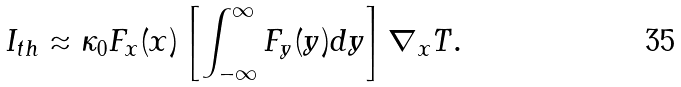Convert formula to latex. <formula><loc_0><loc_0><loc_500><loc_500>I _ { t h } \approx \kappa _ { 0 } F _ { x } ( x ) \left [ \int _ { - \infty } ^ { \infty } F _ { y } ( y ) d y \right ] \nabla _ { x } T .</formula> 